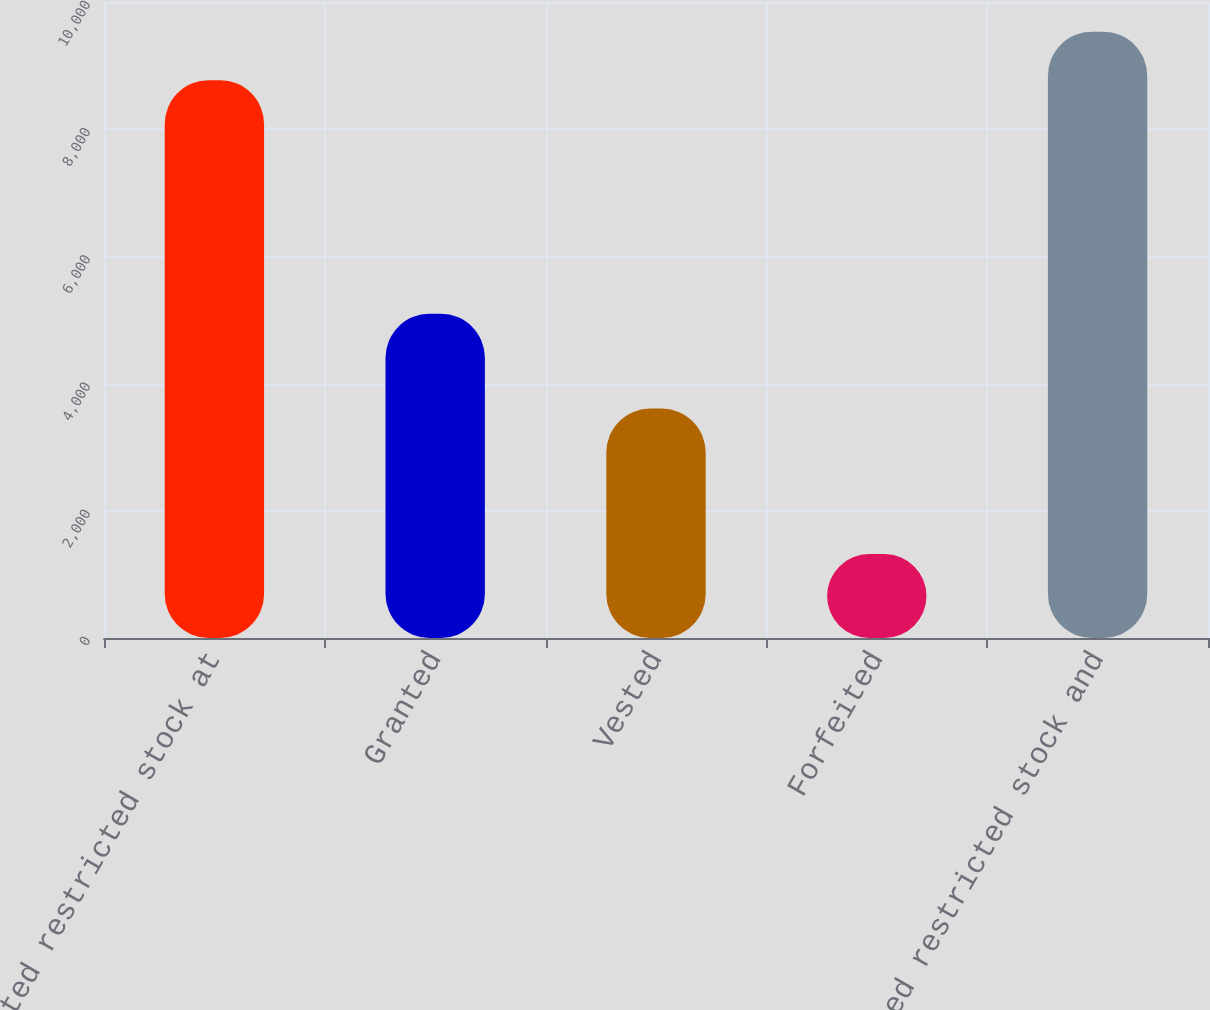<chart> <loc_0><loc_0><loc_500><loc_500><bar_chart><fcel>Nonvested restricted stock at<fcel>Granted<fcel>Vested<fcel>Forfeited<fcel>Nonvested restricted stock and<nl><fcel>8770<fcel>5098<fcel>3607<fcel>1319<fcel>9532.3<nl></chart> 